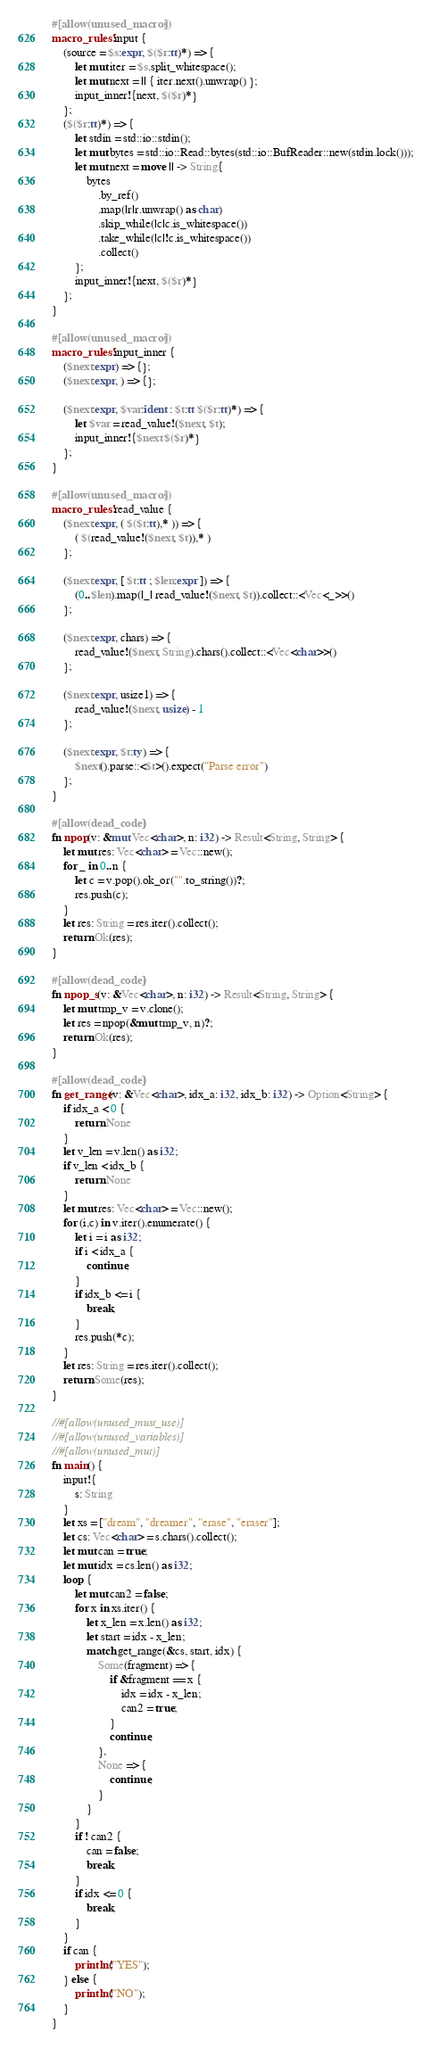Convert code to text. <code><loc_0><loc_0><loc_500><loc_500><_Rust_>#[allow(unused_macros)]
macro_rules! input {
    (source = $s:expr, $($r:tt)*) => {
        let mut iter = $s.split_whitespace();
        let mut next = || { iter.next().unwrap() };
        input_inner!{next, $($r)*}
    };
    ($($r:tt)*) => {
        let stdin = std::io::stdin();
        let mut bytes = std::io::Read::bytes(std::io::BufReader::new(stdin.lock()));
        let mut next = move || -> String{
            bytes
                .by_ref()
                .map(|r|r.unwrap() as char)
                .skip_while(|c|c.is_whitespace())
                .take_while(|c|!c.is_whitespace())
                .collect()
        };
        input_inner!{next, $($r)*}
    };
}

#[allow(unused_macros)]
macro_rules! input_inner {
    ($next:expr) => {};
    ($next:expr, ) => {};

    ($next:expr, $var:ident : $t:tt $($r:tt)*) => {
        let $var = read_value!($next, $t);
        input_inner!{$next $($r)*}
    };
}

#[allow(unused_macros)]
macro_rules! read_value {
    ($next:expr, ( $($t:tt),* )) => {
        ( $(read_value!($next, $t)),* )
    };

    ($next:expr, [ $t:tt ; $len:expr ]) => {
        (0..$len).map(|_| read_value!($next, $t)).collect::<Vec<_>>()
    };

    ($next:expr, chars) => {
        read_value!($next, String).chars().collect::<Vec<char>>()
    };

    ($next:expr, usize1) => {
        read_value!($next, usize) - 1
    };

    ($next:expr, $t:ty) => {
        $next().parse::<$t>().expect("Parse error")
    };
}

#[allow(dead_code)]
fn npop(v: &mut Vec<char>, n: i32) -> Result<String, String> {
    let mut res: Vec<char> = Vec::new();
    for _ in 0..n {
        let c = v.pop().ok_or("".to_string())?;
        res.push(c);
    }
    let res: String = res.iter().collect();
    return Ok(res);
}

#[allow(dead_code)]
fn npop_s(v: &Vec<char>, n: i32) -> Result<String, String> {
    let mut tmp_v = v.clone();
    let res = npop(&mut tmp_v, n)?;
    return Ok(res);
}

#[allow(dead_code)]
fn get_range(v: &Vec<char>, idx_a: i32, idx_b: i32) -> Option<String> {
    if idx_a < 0 {
        return None
    }
    let v_len = v.len() as i32;
    if v_len < idx_b {
        return None
    }
    let mut res: Vec<char> = Vec::new();
    for (i,c) in v.iter().enumerate() {
        let i = i as i32;
        if i < idx_a {
            continue;
        }
        if idx_b <= i {
            break;
        }
        res.push(*c);
    }
    let res: String = res.iter().collect();
    return Some(res);
}

//#[allow(unused_must_use)]
//#[allow(unused_variables)]
//#[allow(unused_mut)]
fn main() {
    input!{
        s: String
    }
    let xs = ["dream", "dreamer", "erase", "eraser"];
    let cs: Vec<char> = s.chars().collect();
    let mut can = true;
    let mut idx = cs.len() as i32;
    loop {
        let mut can2 = false;
        for x in xs.iter() {
            let x_len = x.len() as i32;
            let start = idx - x_len;
            match get_range(&cs, start, idx) {
                Some(fragment) => {
                    if &fragment == x {
                        idx = idx - x_len;
                        can2 = true;
                    }
                    continue;
                },
                None => {
                    continue;
                }
            }
        }
        if ! can2 {
            can = false;
            break;
        }
        if idx <= 0 {
            break;
        }
    }
    if can {
        println!("YES");
    } else {
        println!("NO");
    }
}</code> 